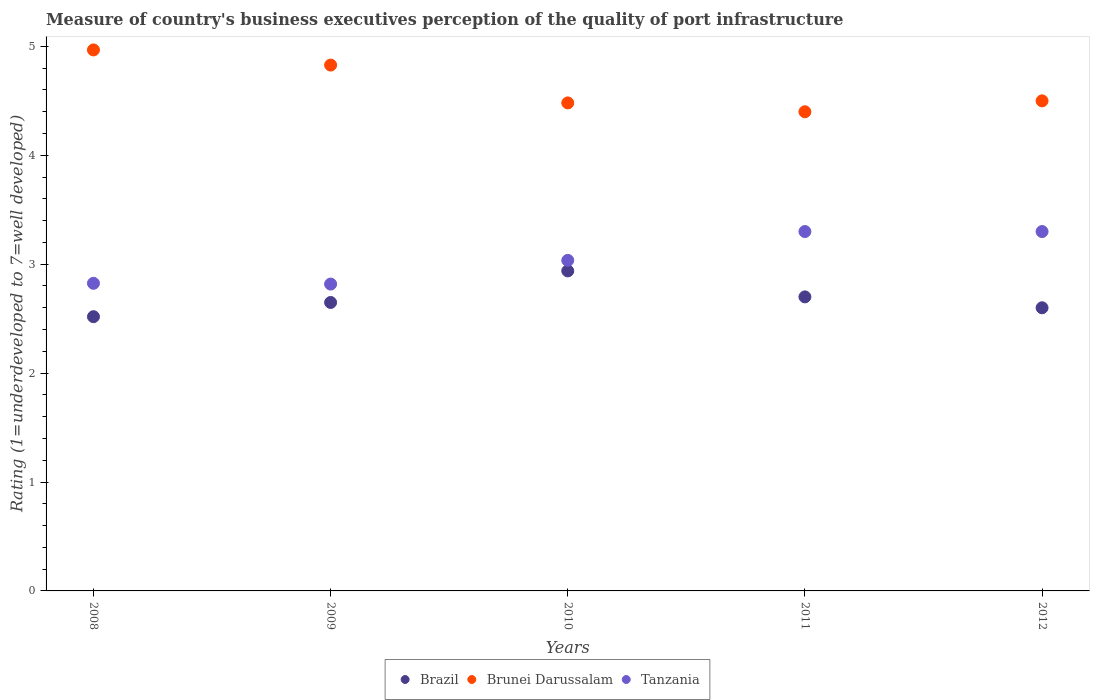How many different coloured dotlines are there?
Ensure brevity in your answer.  3. What is the ratings of the quality of port infrastructure in Tanzania in 2011?
Ensure brevity in your answer.  3.3. Across all years, what is the maximum ratings of the quality of port infrastructure in Brunei Darussalam?
Give a very brief answer. 4.97. Across all years, what is the minimum ratings of the quality of port infrastructure in Tanzania?
Offer a very short reply. 2.82. What is the total ratings of the quality of port infrastructure in Brunei Darussalam in the graph?
Offer a very short reply. 23.18. What is the difference between the ratings of the quality of port infrastructure in Tanzania in 2009 and that in 2010?
Provide a succinct answer. -0.22. What is the difference between the ratings of the quality of port infrastructure in Brunei Darussalam in 2012 and the ratings of the quality of port infrastructure in Tanzania in 2009?
Your response must be concise. 1.68. What is the average ratings of the quality of port infrastructure in Tanzania per year?
Provide a succinct answer. 3.06. In the year 2011, what is the difference between the ratings of the quality of port infrastructure in Brunei Darussalam and ratings of the quality of port infrastructure in Tanzania?
Offer a terse response. 1.1. In how many years, is the ratings of the quality of port infrastructure in Tanzania greater than 4.2?
Offer a very short reply. 0. What is the ratio of the ratings of the quality of port infrastructure in Brazil in 2009 to that in 2011?
Provide a succinct answer. 0.98. Is the difference between the ratings of the quality of port infrastructure in Brunei Darussalam in 2009 and 2010 greater than the difference between the ratings of the quality of port infrastructure in Tanzania in 2009 and 2010?
Offer a very short reply. Yes. What is the difference between the highest and the second highest ratings of the quality of port infrastructure in Brazil?
Offer a very short reply. 0.24. What is the difference between the highest and the lowest ratings of the quality of port infrastructure in Tanzania?
Ensure brevity in your answer.  0.48. In how many years, is the ratings of the quality of port infrastructure in Tanzania greater than the average ratings of the quality of port infrastructure in Tanzania taken over all years?
Give a very brief answer. 2. Is it the case that in every year, the sum of the ratings of the quality of port infrastructure in Tanzania and ratings of the quality of port infrastructure in Brunei Darussalam  is greater than the ratings of the quality of port infrastructure in Brazil?
Provide a short and direct response. Yes. Does the ratings of the quality of port infrastructure in Brazil monotonically increase over the years?
Provide a succinct answer. No. Is the ratings of the quality of port infrastructure in Tanzania strictly greater than the ratings of the quality of port infrastructure in Brunei Darussalam over the years?
Your answer should be compact. No. Is the ratings of the quality of port infrastructure in Tanzania strictly less than the ratings of the quality of port infrastructure in Brazil over the years?
Keep it short and to the point. No. How many years are there in the graph?
Make the answer very short. 5. Does the graph contain any zero values?
Ensure brevity in your answer.  No. Does the graph contain grids?
Provide a short and direct response. No. Where does the legend appear in the graph?
Give a very brief answer. Bottom center. How many legend labels are there?
Give a very brief answer. 3. How are the legend labels stacked?
Offer a very short reply. Horizontal. What is the title of the graph?
Make the answer very short. Measure of country's business executives perception of the quality of port infrastructure. What is the label or title of the Y-axis?
Offer a terse response. Rating (1=underdeveloped to 7=well developed). What is the Rating (1=underdeveloped to 7=well developed) of Brazil in 2008?
Your response must be concise. 2.52. What is the Rating (1=underdeveloped to 7=well developed) of Brunei Darussalam in 2008?
Keep it short and to the point. 4.97. What is the Rating (1=underdeveloped to 7=well developed) of Tanzania in 2008?
Your answer should be compact. 2.82. What is the Rating (1=underdeveloped to 7=well developed) of Brazil in 2009?
Give a very brief answer. 2.65. What is the Rating (1=underdeveloped to 7=well developed) of Brunei Darussalam in 2009?
Make the answer very short. 4.83. What is the Rating (1=underdeveloped to 7=well developed) of Tanzania in 2009?
Offer a very short reply. 2.82. What is the Rating (1=underdeveloped to 7=well developed) of Brazil in 2010?
Your answer should be compact. 2.94. What is the Rating (1=underdeveloped to 7=well developed) in Brunei Darussalam in 2010?
Give a very brief answer. 4.48. What is the Rating (1=underdeveloped to 7=well developed) of Tanzania in 2010?
Provide a succinct answer. 3.04. What is the Rating (1=underdeveloped to 7=well developed) of Brazil in 2011?
Give a very brief answer. 2.7. What is the Rating (1=underdeveloped to 7=well developed) in Tanzania in 2011?
Ensure brevity in your answer.  3.3. What is the Rating (1=underdeveloped to 7=well developed) of Brazil in 2012?
Provide a short and direct response. 2.6. What is the Rating (1=underdeveloped to 7=well developed) of Brunei Darussalam in 2012?
Provide a succinct answer. 4.5. What is the Rating (1=underdeveloped to 7=well developed) of Tanzania in 2012?
Offer a very short reply. 3.3. Across all years, what is the maximum Rating (1=underdeveloped to 7=well developed) in Brazil?
Give a very brief answer. 2.94. Across all years, what is the maximum Rating (1=underdeveloped to 7=well developed) in Brunei Darussalam?
Make the answer very short. 4.97. Across all years, what is the minimum Rating (1=underdeveloped to 7=well developed) in Brazil?
Your answer should be very brief. 2.52. Across all years, what is the minimum Rating (1=underdeveloped to 7=well developed) in Brunei Darussalam?
Give a very brief answer. 4.4. Across all years, what is the minimum Rating (1=underdeveloped to 7=well developed) in Tanzania?
Make the answer very short. 2.82. What is the total Rating (1=underdeveloped to 7=well developed) in Brazil in the graph?
Your answer should be very brief. 13.41. What is the total Rating (1=underdeveloped to 7=well developed) in Brunei Darussalam in the graph?
Offer a terse response. 23.18. What is the total Rating (1=underdeveloped to 7=well developed) of Tanzania in the graph?
Your answer should be very brief. 15.28. What is the difference between the Rating (1=underdeveloped to 7=well developed) in Brazil in 2008 and that in 2009?
Make the answer very short. -0.13. What is the difference between the Rating (1=underdeveloped to 7=well developed) of Brunei Darussalam in 2008 and that in 2009?
Provide a short and direct response. 0.14. What is the difference between the Rating (1=underdeveloped to 7=well developed) of Tanzania in 2008 and that in 2009?
Provide a short and direct response. 0.01. What is the difference between the Rating (1=underdeveloped to 7=well developed) in Brazil in 2008 and that in 2010?
Provide a short and direct response. -0.42. What is the difference between the Rating (1=underdeveloped to 7=well developed) in Brunei Darussalam in 2008 and that in 2010?
Provide a short and direct response. 0.49. What is the difference between the Rating (1=underdeveloped to 7=well developed) of Tanzania in 2008 and that in 2010?
Your response must be concise. -0.21. What is the difference between the Rating (1=underdeveloped to 7=well developed) in Brazil in 2008 and that in 2011?
Your answer should be compact. -0.18. What is the difference between the Rating (1=underdeveloped to 7=well developed) of Brunei Darussalam in 2008 and that in 2011?
Offer a very short reply. 0.57. What is the difference between the Rating (1=underdeveloped to 7=well developed) of Tanzania in 2008 and that in 2011?
Keep it short and to the point. -0.48. What is the difference between the Rating (1=underdeveloped to 7=well developed) in Brazil in 2008 and that in 2012?
Make the answer very short. -0.08. What is the difference between the Rating (1=underdeveloped to 7=well developed) of Brunei Darussalam in 2008 and that in 2012?
Ensure brevity in your answer.  0.47. What is the difference between the Rating (1=underdeveloped to 7=well developed) of Tanzania in 2008 and that in 2012?
Ensure brevity in your answer.  -0.48. What is the difference between the Rating (1=underdeveloped to 7=well developed) of Brazil in 2009 and that in 2010?
Give a very brief answer. -0.29. What is the difference between the Rating (1=underdeveloped to 7=well developed) of Brunei Darussalam in 2009 and that in 2010?
Provide a short and direct response. 0.35. What is the difference between the Rating (1=underdeveloped to 7=well developed) of Tanzania in 2009 and that in 2010?
Give a very brief answer. -0.22. What is the difference between the Rating (1=underdeveloped to 7=well developed) of Brazil in 2009 and that in 2011?
Offer a terse response. -0.05. What is the difference between the Rating (1=underdeveloped to 7=well developed) of Brunei Darussalam in 2009 and that in 2011?
Your response must be concise. 0.43. What is the difference between the Rating (1=underdeveloped to 7=well developed) of Tanzania in 2009 and that in 2011?
Keep it short and to the point. -0.48. What is the difference between the Rating (1=underdeveloped to 7=well developed) in Brazil in 2009 and that in 2012?
Provide a short and direct response. 0.05. What is the difference between the Rating (1=underdeveloped to 7=well developed) of Brunei Darussalam in 2009 and that in 2012?
Ensure brevity in your answer.  0.33. What is the difference between the Rating (1=underdeveloped to 7=well developed) of Tanzania in 2009 and that in 2012?
Your response must be concise. -0.48. What is the difference between the Rating (1=underdeveloped to 7=well developed) in Brazil in 2010 and that in 2011?
Offer a terse response. 0.24. What is the difference between the Rating (1=underdeveloped to 7=well developed) of Brunei Darussalam in 2010 and that in 2011?
Keep it short and to the point. 0.08. What is the difference between the Rating (1=underdeveloped to 7=well developed) of Tanzania in 2010 and that in 2011?
Your response must be concise. -0.26. What is the difference between the Rating (1=underdeveloped to 7=well developed) of Brazil in 2010 and that in 2012?
Your answer should be very brief. 0.34. What is the difference between the Rating (1=underdeveloped to 7=well developed) of Brunei Darussalam in 2010 and that in 2012?
Give a very brief answer. -0.02. What is the difference between the Rating (1=underdeveloped to 7=well developed) of Tanzania in 2010 and that in 2012?
Give a very brief answer. -0.26. What is the difference between the Rating (1=underdeveloped to 7=well developed) of Brunei Darussalam in 2011 and that in 2012?
Ensure brevity in your answer.  -0.1. What is the difference between the Rating (1=underdeveloped to 7=well developed) in Brazil in 2008 and the Rating (1=underdeveloped to 7=well developed) in Brunei Darussalam in 2009?
Your answer should be very brief. -2.31. What is the difference between the Rating (1=underdeveloped to 7=well developed) in Brazil in 2008 and the Rating (1=underdeveloped to 7=well developed) in Tanzania in 2009?
Keep it short and to the point. -0.3. What is the difference between the Rating (1=underdeveloped to 7=well developed) of Brunei Darussalam in 2008 and the Rating (1=underdeveloped to 7=well developed) of Tanzania in 2009?
Ensure brevity in your answer.  2.15. What is the difference between the Rating (1=underdeveloped to 7=well developed) in Brazil in 2008 and the Rating (1=underdeveloped to 7=well developed) in Brunei Darussalam in 2010?
Give a very brief answer. -1.96. What is the difference between the Rating (1=underdeveloped to 7=well developed) of Brazil in 2008 and the Rating (1=underdeveloped to 7=well developed) of Tanzania in 2010?
Keep it short and to the point. -0.52. What is the difference between the Rating (1=underdeveloped to 7=well developed) of Brunei Darussalam in 2008 and the Rating (1=underdeveloped to 7=well developed) of Tanzania in 2010?
Your answer should be compact. 1.93. What is the difference between the Rating (1=underdeveloped to 7=well developed) in Brazil in 2008 and the Rating (1=underdeveloped to 7=well developed) in Brunei Darussalam in 2011?
Ensure brevity in your answer.  -1.88. What is the difference between the Rating (1=underdeveloped to 7=well developed) of Brazil in 2008 and the Rating (1=underdeveloped to 7=well developed) of Tanzania in 2011?
Provide a succinct answer. -0.78. What is the difference between the Rating (1=underdeveloped to 7=well developed) of Brunei Darussalam in 2008 and the Rating (1=underdeveloped to 7=well developed) of Tanzania in 2011?
Your response must be concise. 1.67. What is the difference between the Rating (1=underdeveloped to 7=well developed) of Brazil in 2008 and the Rating (1=underdeveloped to 7=well developed) of Brunei Darussalam in 2012?
Provide a succinct answer. -1.98. What is the difference between the Rating (1=underdeveloped to 7=well developed) of Brazil in 2008 and the Rating (1=underdeveloped to 7=well developed) of Tanzania in 2012?
Provide a succinct answer. -0.78. What is the difference between the Rating (1=underdeveloped to 7=well developed) of Brunei Darussalam in 2008 and the Rating (1=underdeveloped to 7=well developed) of Tanzania in 2012?
Keep it short and to the point. 1.67. What is the difference between the Rating (1=underdeveloped to 7=well developed) in Brazil in 2009 and the Rating (1=underdeveloped to 7=well developed) in Brunei Darussalam in 2010?
Ensure brevity in your answer.  -1.83. What is the difference between the Rating (1=underdeveloped to 7=well developed) in Brazil in 2009 and the Rating (1=underdeveloped to 7=well developed) in Tanzania in 2010?
Provide a succinct answer. -0.39. What is the difference between the Rating (1=underdeveloped to 7=well developed) of Brunei Darussalam in 2009 and the Rating (1=underdeveloped to 7=well developed) of Tanzania in 2010?
Keep it short and to the point. 1.79. What is the difference between the Rating (1=underdeveloped to 7=well developed) of Brazil in 2009 and the Rating (1=underdeveloped to 7=well developed) of Brunei Darussalam in 2011?
Your answer should be compact. -1.75. What is the difference between the Rating (1=underdeveloped to 7=well developed) in Brazil in 2009 and the Rating (1=underdeveloped to 7=well developed) in Tanzania in 2011?
Offer a very short reply. -0.65. What is the difference between the Rating (1=underdeveloped to 7=well developed) in Brunei Darussalam in 2009 and the Rating (1=underdeveloped to 7=well developed) in Tanzania in 2011?
Keep it short and to the point. 1.53. What is the difference between the Rating (1=underdeveloped to 7=well developed) in Brazil in 2009 and the Rating (1=underdeveloped to 7=well developed) in Brunei Darussalam in 2012?
Give a very brief answer. -1.85. What is the difference between the Rating (1=underdeveloped to 7=well developed) in Brazil in 2009 and the Rating (1=underdeveloped to 7=well developed) in Tanzania in 2012?
Your answer should be very brief. -0.65. What is the difference between the Rating (1=underdeveloped to 7=well developed) in Brunei Darussalam in 2009 and the Rating (1=underdeveloped to 7=well developed) in Tanzania in 2012?
Your answer should be very brief. 1.53. What is the difference between the Rating (1=underdeveloped to 7=well developed) of Brazil in 2010 and the Rating (1=underdeveloped to 7=well developed) of Brunei Darussalam in 2011?
Offer a very short reply. -1.46. What is the difference between the Rating (1=underdeveloped to 7=well developed) of Brazil in 2010 and the Rating (1=underdeveloped to 7=well developed) of Tanzania in 2011?
Offer a very short reply. -0.36. What is the difference between the Rating (1=underdeveloped to 7=well developed) in Brunei Darussalam in 2010 and the Rating (1=underdeveloped to 7=well developed) in Tanzania in 2011?
Give a very brief answer. 1.18. What is the difference between the Rating (1=underdeveloped to 7=well developed) in Brazil in 2010 and the Rating (1=underdeveloped to 7=well developed) in Brunei Darussalam in 2012?
Your answer should be very brief. -1.56. What is the difference between the Rating (1=underdeveloped to 7=well developed) of Brazil in 2010 and the Rating (1=underdeveloped to 7=well developed) of Tanzania in 2012?
Offer a terse response. -0.36. What is the difference between the Rating (1=underdeveloped to 7=well developed) of Brunei Darussalam in 2010 and the Rating (1=underdeveloped to 7=well developed) of Tanzania in 2012?
Give a very brief answer. 1.18. What is the difference between the Rating (1=underdeveloped to 7=well developed) in Brazil in 2011 and the Rating (1=underdeveloped to 7=well developed) in Brunei Darussalam in 2012?
Your answer should be very brief. -1.8. What is the difference between the Rating (1=underdeveloped to 7=well developed) of Brazil in 2011 and the Rating (1=underdeveloped to 7=well developed) of Tanzania in 2012?
Your answer should be compact. -0.6. What is the difference between the Rating (1=underdeveloped to 7=well developed) in Brunei Darussalam in 2011 and the Rating (1=underdeveloped to 7=well developed) in Tanzania in 2012?
Provide a succinct answer. 1.1. What is the average Rating (1=underdeveloped to 7=well developed) in Brazil per year?
Offer a very short reply. 2.68. What is the average Rating (1=underdeveloped to 7=well developed) of Brunei Darussalam per year?
Offer a very short reply. 4.64. What is the average Rating (1=underdeveloped to 7=well developed) in Tanzania per year?
Your answer should be very brief. 3.06. In the year 2008, what is the difference between the Rating (1=underdeveloped to 7=well developed) of Brazil and Rating (1=underdeveloped to 7=well developed) of Brunei Darussalam?
Make the answer very short. -2.45. In the year 2008, what is the difference between the Rating (1=underdeveloped to 7=well developed) in Brazil and Rating (1=underdeveloped to 7=well developed) in Tanzania?
Keep it short and to the point. -0.31. In the year 2008, what is the difference between the Rating (1=underdeveloped to 7=well developed) in Brunei Darussalam and Rating (1=underdeveloped to 7=well developed) in Tanzania?
Your response must be concise. 2.14. In the year 2009, what is the difference between the Rating (1=underdeveloped to 7=well developed) of Brazil and Rating (1=underdeveloped to 7=well developed) of Brunei Darussalam?
Ensure brevity in your answer.  -2.18. In the year 2009, what is the difference between the Rating (1=underdeveloped to 7=well developed) in Brazil and Rating (1=underdeveloped to 7=well developed) in Tanzania?
Your answer should be compact. -0.17. In the year 2009, what is the difference between the Rating (1=underdeveloped to 7=well developed) of Brunei Darussalam and Rating (1=underdeveloped to 7=well developed) of Tanzania?
Ensure brevity in your answer.  2.01. In the year 2010, what is the difference between the Rating (1=underdeveloped to 7=well developed) in Brazil and Rating (1=underdeveloped to 7=well developed) in Brunei Darussalam?
Provide a succinct answer. -1.54. In the year 2010, what is the difference between the Rating (1=underdeveloped to 7=well developed) of Brazil and Rating (1=underdeveloped to 7=well developed) of Tanzania?
Ensure brevity in your answer.  -0.1. In the year 2010, what is the difference between the Rating (1=underdeveloped to 7=well developed) in Brunei Darussalam and Rating (1=underdeveloped to 7=well developed) in Tanzania?
Your response must be concise. 1.45. In the year 2011, what is the difference between the Rating (1=underdeveloped to 7=well developed) of Brazil and Rating (1=underdeveloped to 7=well developed) of Brunei Darussalam?
Your response must be concise. -1.7. In the year 2011, what is the difference between the Rating (1=underdeveloped to 7=well developed) in Brazil and Rating (1=underdeveloped to 7=well developed) in Tanzania?
Provide a short and direct response. -0.6. In the year 2011, what is the difference between the Rating (1=underdeveloped to 7=well developed) of Brunei Darussalam and Rating (1=underdeveloped to 7=well developed) of Tanzania?
Provide a short and direct response. 1.1. What is the ratio of the Rating (1=underdeveloped to 7=well developed) of Brazil in 2008 to that in 2009?
Ensure brevity in your answer.  0.95. What is the ratio of the Rating (1=underdeveloped to 7=well developed) of Brunei Darussalam in 2008 to that in 2009?
Give a very brief answer. 1.03. What is the ratio of the Rating (1=underdeveloped to 7=well developed) in Tanzania in 2008 to that in 2009?
Ensure brevity in your answer.  1. What is the ratio of the Rating (1=underdeveloped to 7=well developed) in Brazil in 2008 to that in 2010?
Provide a short and direct response. 0.86. What is the ratio of the Rating (1=underdeveloped to 7=well developed) in Brunei Darussalam in 2008 to that in 2010?
Provide a short and direct response. 1.11. What is the ratio of the Rating (1=underdeveloped to 7=well developed) in Tanzania in 2008 to that in 2010?
Keep it short and to the point. 0.93. What is the ratio of the Rating (1=underdeveloped to 7=well developed) of Brazil in 2008 to that in 2011?
Offer a very short reply. 0.93. What is the ratio of the Rating (1=underdeveloped to 7=well developed) in Brunei Darussalam in 2008 to that in 2011?
Offer a terse response. 1.13. What is the ratio of the Rating (1=underdeveloped to 7=well developed) of Tanzania in 2008 to that in 2011?
Provide a short and direct response. 0.86. What is the ratio of the Rating (1=underdeveloped to 7=well developed) of Brazil in 2008 to that in 2012?
Keep it short and to the point. 0.97. What is the ratio of the Rating (1=underdeveloped to 7=well developed) of Brunei Darussalam in 2008 to that in 2012?
Your answer should be very brief. 1.1. What is the ratio of the Rating (1=underdeveloped to 7=well developed) in Tanzania in 2008 to that in 2012?
Make the answer very short. 0.86. What is the ratio of the Rating (1=underdeveloped to 7=well developed) in Brazil in 2009 to that in 2010?
Ensure brevity in your answer.  0.9. What is the ratio of the Rating (1=underdeveloped to 7=well developed) of Brunei Darussalam in 2009 to that in 2010?
Keep it short and to the point. 1.08. What is the ratio of the Rating (1=underdeveloped to 7=well developed) in Tanzania in 2009 to that in 2010?
Offer a terse response. 0.93. What is the ratio of the Rating (1=underdeveloped to 7=well developed) in Brunei Darussalam in 2009 to that in 2011?
Provide a succinct answer. 1.1. What is the ratio of the Rating (1=underdeveloped to 7=well developed) of Tanzania in 2009 to that in 2011?
Your answer should be compact. 0.85. What is the ratio of the Rating (1=underdeveloped to 7=well developed) of Brazil in 2009 to that in 2012?
Your answer should be compact. 1.02. What is the ratio of the Rating (1=underdeveloped to 7=well developed) in Brunei Darussalam in 2009 to that in 2012?
Ensure brevity in your answer.  1.07. What is the ratio of the Rating (1=underdeveloped to 7=well developed) in Tanzania in 2009 to that in 2012?
Make the answer very short. 0.85. What is the ratio of the Rating (1=underdeveloped to 7=well developed) in Brazil in 2010 to that in 2011?
Give a very brief answer. 1.09. What is the ratio of the Rating (1=underdeveloped to 7=well developed) in Brunei Darussalam in 2010 to that in 2011?
Provide a short and direct response. 1.02. What is the ratio of the Rating (1=underdeveloped to 7=well developed) of Tanzania in 2010 to that in 2011?
Your response must be concise. 0.92. What is the ratio of the Rating (1=underdeveloped to 7=well developed) of Brazil in 2010 to that in 2012?
Your answer should be compact. 1.13. What is the ratio of the Rating (1=underdeveloped to 7=well developed) of Tanzania in 2010 to that in 2012?
Your answer should be compact. 0.92. What is the ratio of the Rating (1=underdeveloped to 7=well developed) in Brazil in 2011 to that in 2012?
Ensure brevity in your answer.  1.04. What is the ratio of the Rating (1=underdeveloped to 7=well developed) of Brunei Darussalam in 2011 to that in 2012?
Provide a short and direct response. 0.98. What is the ratio of the Rating (1=underdeveloped to 7=well developed) of Tanzania in 2011 to that in 2012?
Your answer should be compact. 1. What is the difference between the highest and the second highest Rating (1=underdeveloped to 7=well developed) in Brazil?
Give a very brief answer. 0.24. What is the difference between the highest and the second highest Rating (1=underdeveloped to 7=well developed) of Brunei Darussalam?
Give a very brief answer. 0.14. What is the difference between the highest and the lowest Rating (1=underdeveloped to 7=well developed) in Brazil?
Offer a very short reply. 0.42. What is the difference between the highest and the lowest Rating (1=underdeveloped to 7=well developed) in Brunei Darussalam?
Offer a very short reply. 0.57. What is the difference between the highest and the lowest Rating (1=underdeveloped to 7=well developed) of Tanzania?
Your answer should be compact. 0.48. 